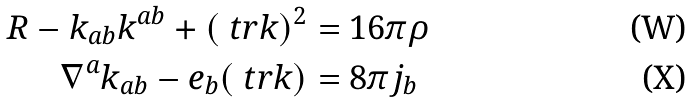Convert formula to latex. <formula><loc_0><loc_0><loc_500><loc_500>R - k _ { a b } k ^ { a b } + ( \ t r k ) ^ { 2 } & = 1 6 \pi \rho \\ \nabla ^ { a } k _ { a b } - e _ { b } ( \ t r k ) & = 8 \pi j _ { b }</formula> 